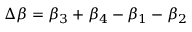<formula> <loc_0><loc_0><loc_500><loc_500>\Delta \beta = \beta _ { 3 } + \beta _ { 4 } - \beta _ { 1 } - \beta _ { 2 }</formula> 